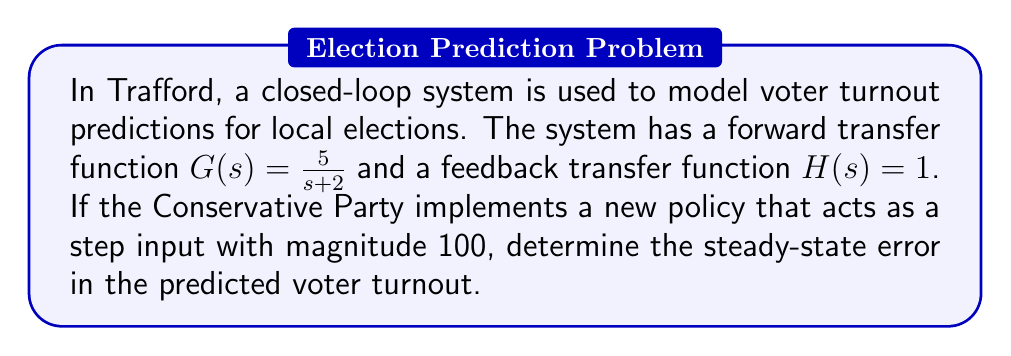Can you solve this math problem? To solve this problem, we'll follow these steps:

1) First, we need to determine the open-loop transfer function:
   $G(s)H(s) = \frac{5}{s+2} \cdot 1 = \frac{5}{s+2}$

2) The closed-loop transfer function is:
   $T(s) = \frac{G(s)}{1+G(s)H(s)} = \frac{\frac{5}{s+2}}{1+\frac{5}{s+2}} = \frac{5}{s+7}$

3) For a step input, the steady-state error is given by:
   $e_{ss} = \frac{1}{1+K}$, where $K$ is the static position error constant.

4) To find $K$, we use the final value theorem:
   $K = \lim_{s \to 0} sG(s)H(s) = \lim_{s \to 0} s\frac{5}{s+2} = \frac{5}{2}$

5) Now we can calculate the steady-state error:
   $e_{ss} = \frac{1}{1+K} = \frac{1}{1+\frac{5}{2}} = \frac{2}{7}$

6) Since the input magnitude is 100, we multiply our error by 100:
   $\text{Actual error} = 100 \cdot \frac{2}{7} = \frac{200}{7} \approx 28.57$

This means that the steady-state error in the predicted voter turnout is approximately 28.57 voters, or about 28.57% of the input magnitude.
Answer: The steady-state error in the predicted voter turnout is $\frac{200}{7}$ voters, or approximately 28.57 voters. 